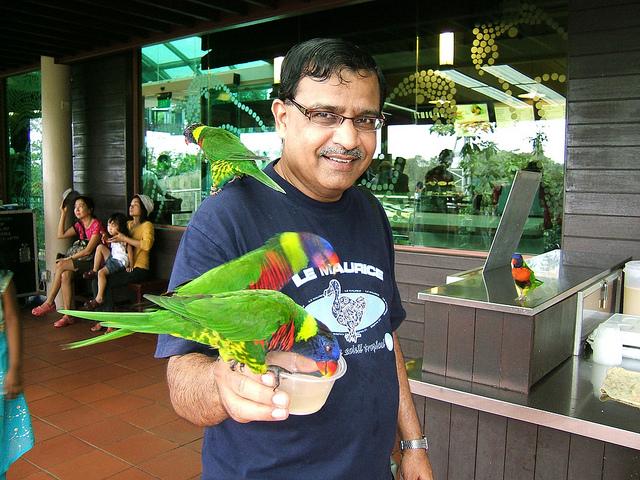How many people are sitting in the background?
Short answer required. 3. What is the feeding?
Keep it brief. Bird. How many birds is this man holding?
Concise answer only. 2. Is this photo outdoors?
Write a very short answer. Yes. 